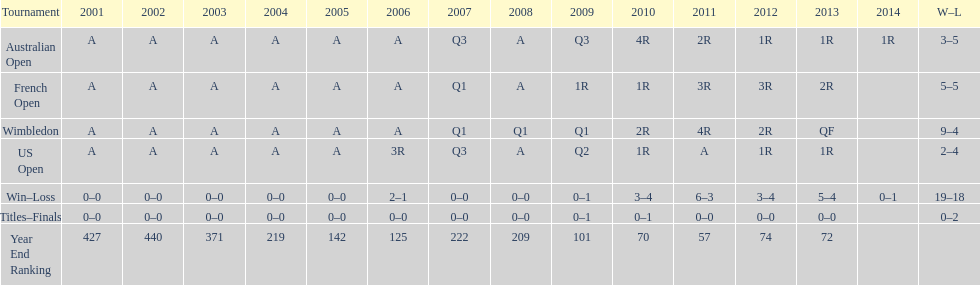How many total matches took place between 2001 and 2014? 37. 